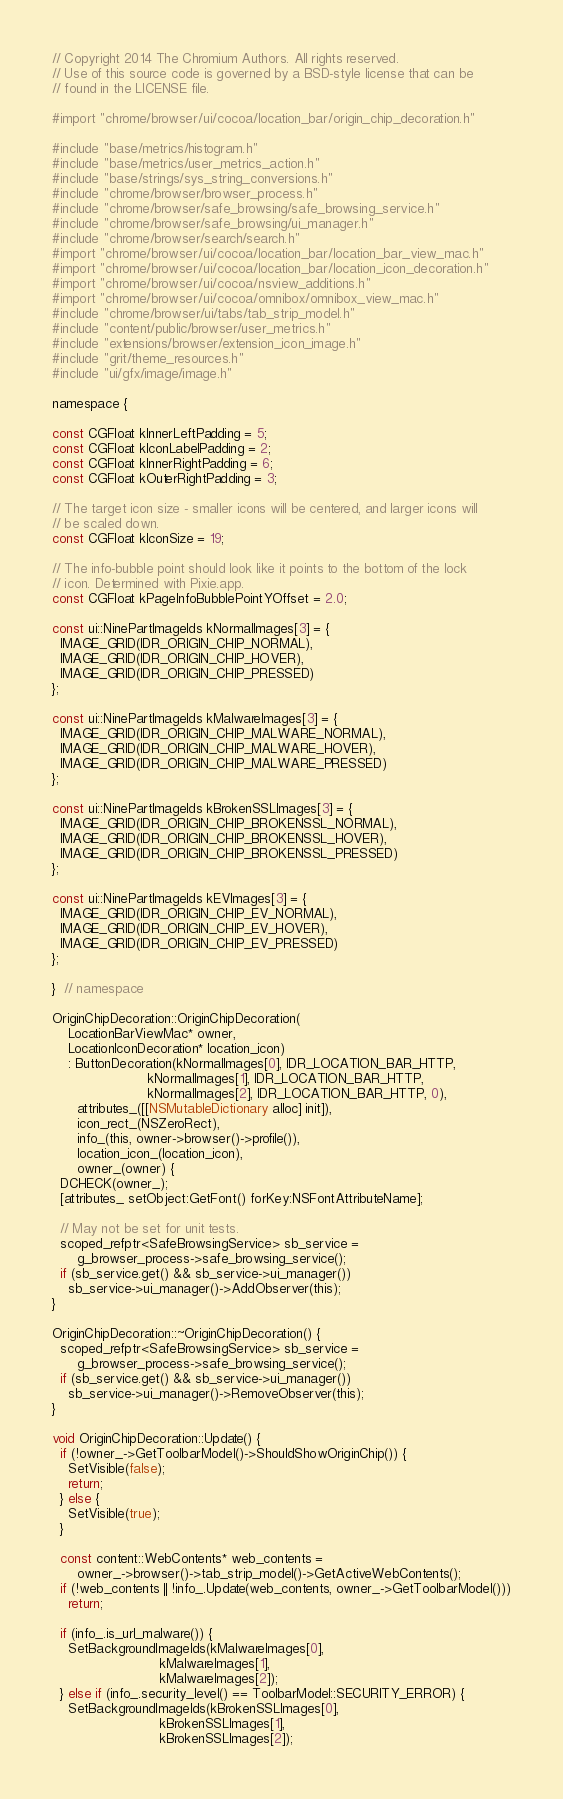Convert code to text. <code><loc_0><loc_0><loc_500><loc_500><_ObjectiveC_>// Copyright 2014 The Chromium Authors. All rights reserved.
// Use of this source code is governed by a BSD-style license that can be
// found in the LICENSE file.

#import "chrome/browser/ui/cocoa/location_bar/origin_chip_decoration.h"

#include "base/metrics/histogram.h"
#include "base/metrics/user_metrics_action.h"
#include "base/strings/sys_string_conversions.h"
#include "chrome/browser/browser_process.h"
#include "chrome/browser/safe_browsing/safe_browsing_service.h"
#include "chrome/browser/safe_browsing/ui_manager.h"
#include "chrome/browser/search/search.h"
#import "chrome/browser/ui/cocoa/location_bar/location_bar_view_mac.h"
#import "chrome/browser/ui/cocoa/location_bar/location_icon_decoration.h"
#import "chrome/browser/ui/cocoa/nsview_additions.h"
#import "chrome/browser/ui/cocoa/omnibox/omnibox_view_mac.h"
#include "chrome/browser/ui/tabs/tab_strip_model.h"
#include "content/public/browser/user_metrics.h"
#include "extensions/browser/extension_icon_image.h"
#include "grit/theme_resources.h"
#include "ui/gfx/image/image.h"

namespace {

const CGFloat kInnerLeftPadding = 5;
const CGFloat kIconLabelPadding = 2;
const CGFloat kInnerRightPadding = 6;
const CGFloat kOuterRightPadding = 3;

// The target icon size - smaller icons will be centered, and larger icons will
// be scaled down.
const CGFloat kIconSize = 19;

// The info-bubble point should look like it points to the bottom of the lock
// icon. Determined with Pixie.app.
const CGFloat kPageInfoBubblePointYOffset = 2.0;

const ui::NinePartImageIds kNormalImages[3] = {
  IMAGE_GRID(IDR_ORIGIN_CHIP_NORMAL),
  IMAGE_GRID(IDR_ORIGIN_CHIP_HOVER),
  IMAGE_GRID(IDR_ORIGIN_CHIP_PRESSED)
};

const ui::NinePartImageIds kMalwareImages[3] = {
  IMAGE_GRID(IDR_ORIGIN_CHIP_MALWARE_NORMAL),
  IMAGE_GRID(IDR_ORIGIN_CHIP_MALWARE_HOVER),
  IMAGE_GRID(IDR_ORIGIN_CHIP_MALWARE_PRESSED)
};

const ui::NinePartImageIds kBrokenSSLImages[3] = {
  IMAGE_GRID(IDR_ORIGIN_CHIP_BROKENSSL_NORMAL),
  IMAGE_GRID(IDR_ORIGIN_CHIP_BROKENSSL_HOVER),
  IMAGE_GRID(IDR_ORIGIN_CHIP_BROKENSSL_PRESSED)
};

const ui::NinePartImageIds kEVImages[3] = {
  IMAGE_GRID(IDR_ORIGIN_CHIP_EV_NORMAL),
  IMAGE_GRID(IDR_ORIGIN_CHIP_EV_HOVER),
  IMAGE_GRID(IDR_ORIGIN_CHIP_EV_PRESSED)
};

}  // namespace

OriginChipDecoration::OriginChipDecoration(
    LocationBarViewMac* owner,
    LocationIconDecoration* location_icon)
    : ButtonDecoration(kNormalImages[0], IDR_LOCATION_BAR_HTTP,
                       kNormalImages[1], IDR_LOCATION_BAR_HTTP,
                       kNormalImages[2], IDR_LOCATION_BAR_HTTP, 0),
      attributes_([[NSMutableDictionary alloc] init]),
      icon_rect_(NSZeroRect),
      info_(this, owner->browser()->profile()),
      location_icon_(location_icon),
      owner_(owner) {
  DCHECK(owner_);
  [attributes_ setObject:GetFont() forKey:NSFontAttributeName];

  // May not be set for unit tests.
  scoped_refptr<SafeBrowsingService> sb_service =
      g_browser_process->safe_browsing_service();
  if (sb_service.get() && sb_service->ui_manager())
    sb_service->ui_manager()->AddObserver(this);
}

OriginChipDecoration::~OriginChipDecoration() {
  scoped_refptr<SafeBrowsingService> sb_service =
      g_browser_process->safe_browsing_service();
  if (sb_service.get() && sb_service->ui_manager())
    sb_service->ui_manager()->RemoveObserver(this);
}

void OriginChipDecoration::Update() {
  if (!owner_->GetToolbarModel()->ShouldShowOriginChip()) {
    SetVisible(false);
    return;
  } else {
    SetVisible(true);
  }

  const content::WebContents* web_contents =
      owner_->browser()->tab_strip_model()->GetActiveWebContents();
  if (!web_contents || !info_.Update(web_contents, owner_->GetToolbarModel()))
    return;

  if (info_.is_url_malware()) {
    SetBackgroundImageIds(kMalwareImages[0],
                          kMalwareImages[1],
                          kMalwareImages[2]);
  } else if (info_.security_level() == ToolbarModel::SECURITY_ERROR) {
    SetBackgroundImageIds(kBrokenSSLImages[0],
                          kBrokenSSLImages[1],
                          kBrokenSSLImages[2]);</code> 